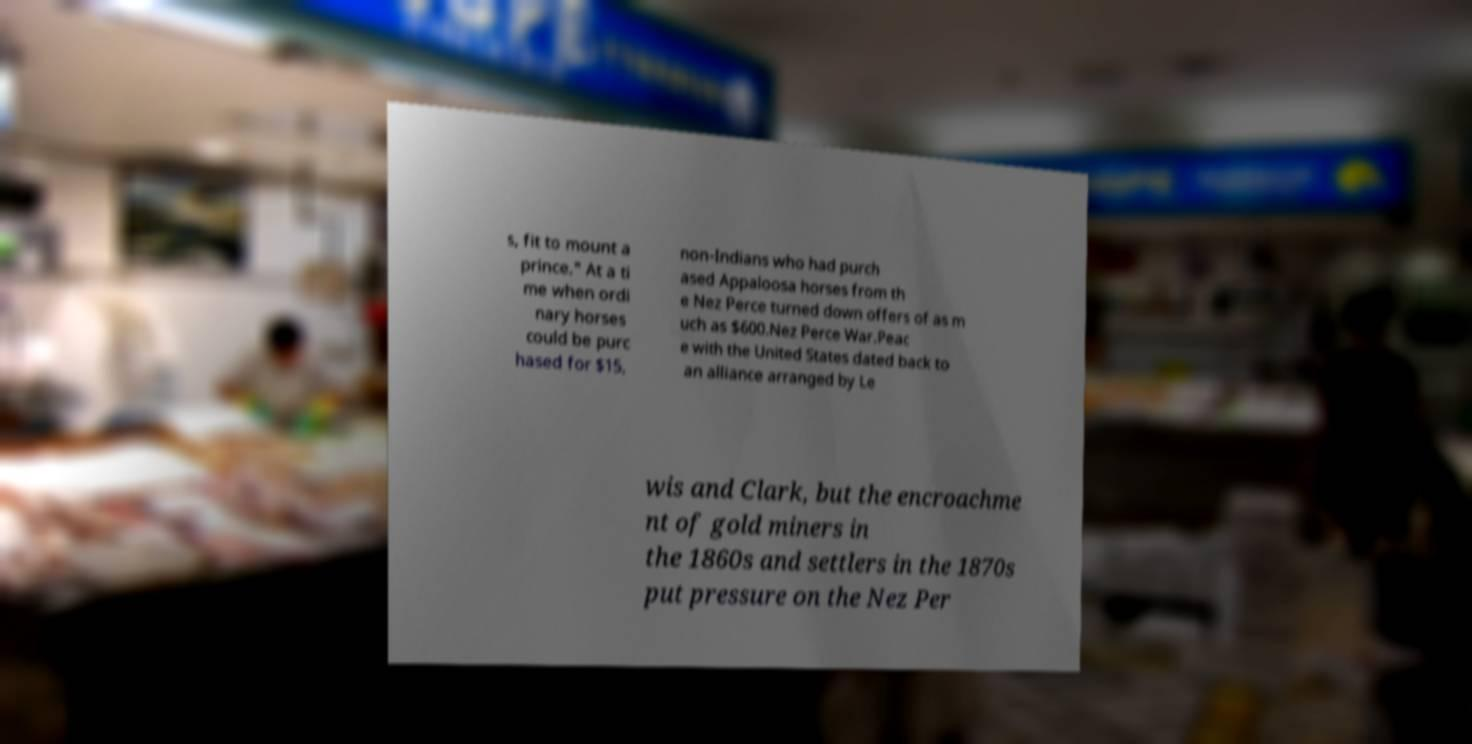Please read and relay the text visible in this image. What does it say? s, fit to mount a prince." At a ti me when ordi nary horses could be purc hased for $15, non-Indians who had purch ased Appaloosa horses from th e Nez Perce turned down offers of as m uch as $600.Nez Perce War.Peac e with the United States dated back to an alliance arranged by Le wis and Clark, but the encroachme nt of gold miners in the 1860s and settlers in the 1870s put pressure on the Nez Per 